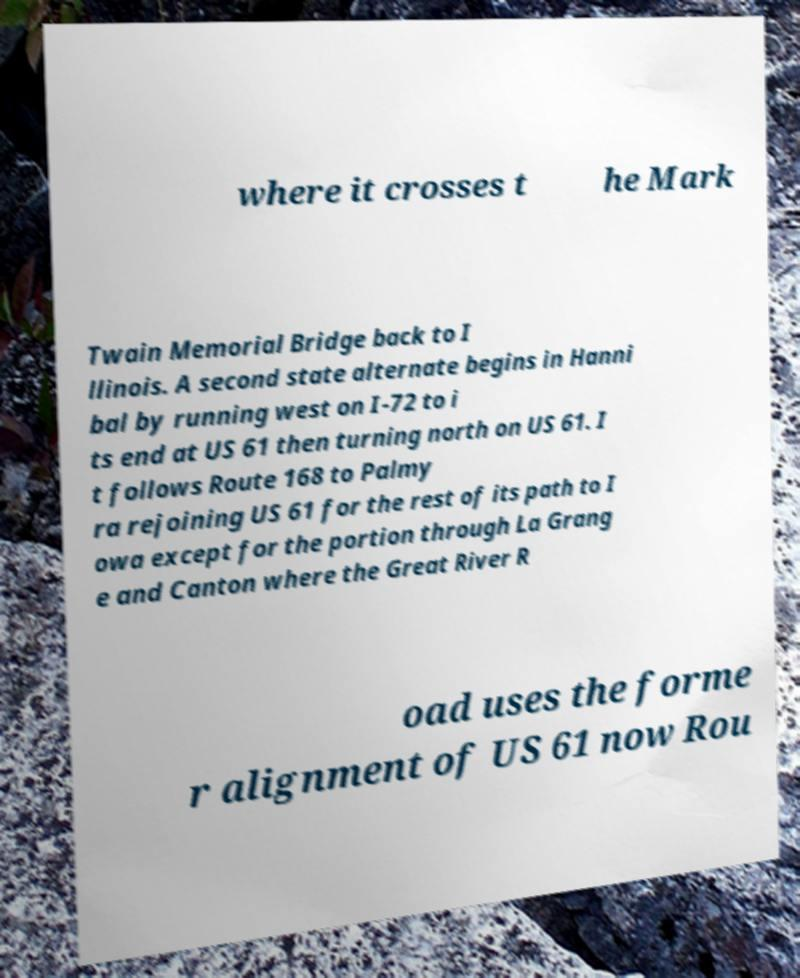Can you read and provide the text displayed in the image?This photo seems to have some interesting text. Can you extract and type it out for me? where it crosses t he Mark Twain Memorial Bridge back to I llinois. A second state alternate begins in Hanni bal by running west on I-72 to i ts end at US 61 then turning north on US 61. I t follows Route 168 to Palmy ra rejoining US 61 for the rest of its path to I owa except for the portion through La Grang e and Canton where the Great River R oad uses the forme r alignment of US 61 now Rou 